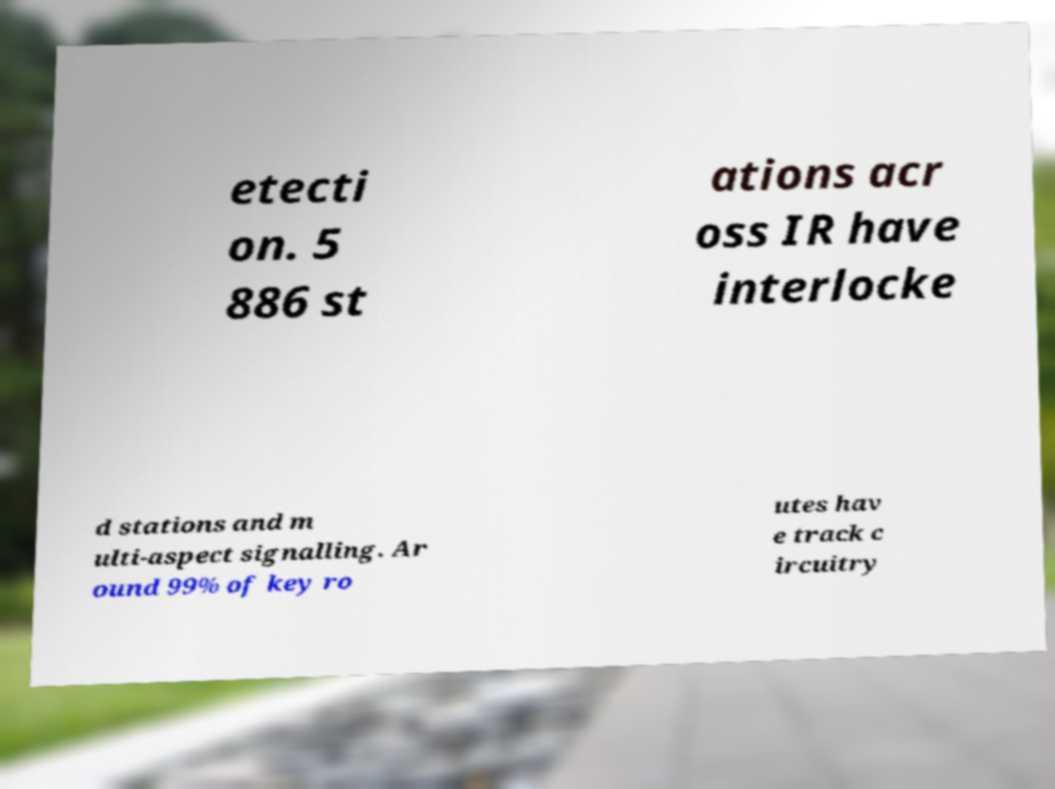Please read and relay the text visible in this image. What does it say? etecti on. 5 886 st ations acr oss IR have interlocke d stations and m ulti-aspect signalling. Ar ound 99% of key ro utes hav e track c ircuitry 